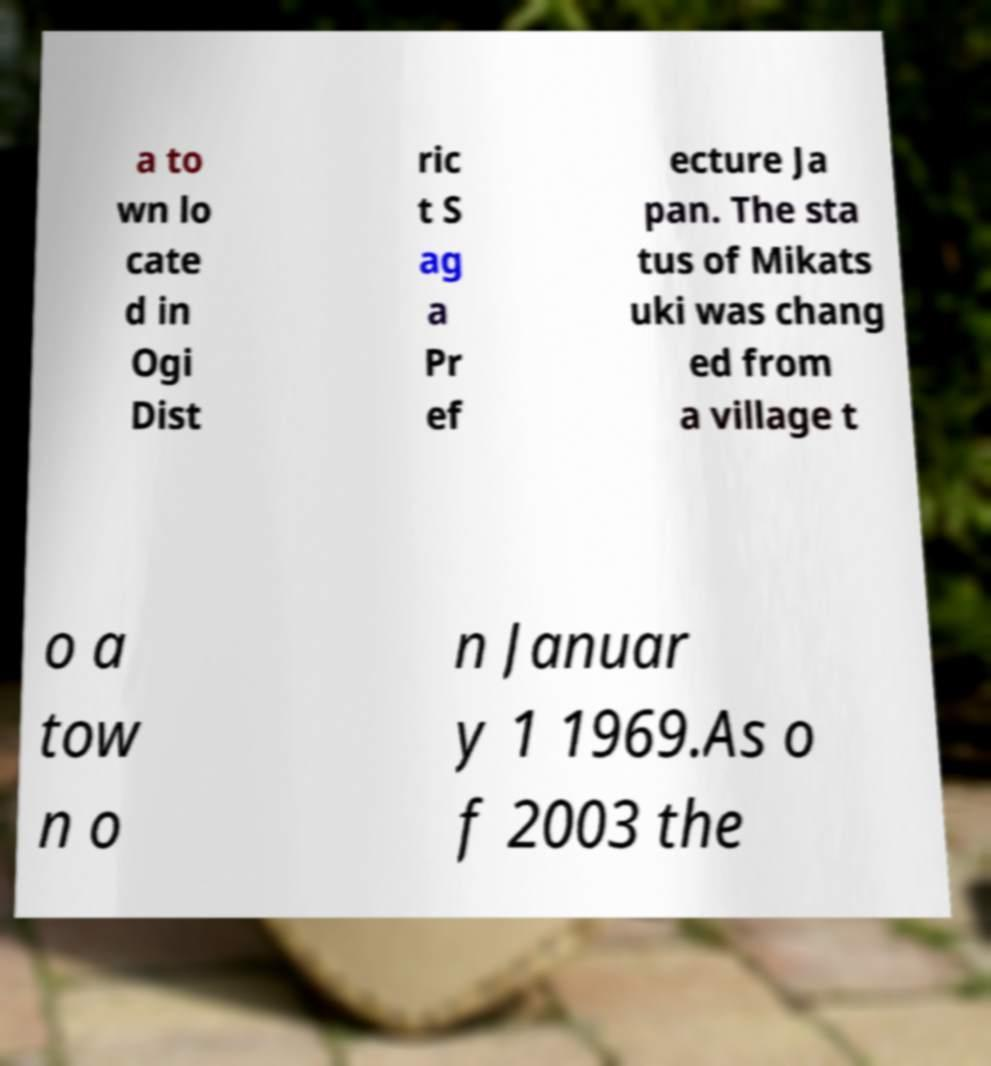Please identify and transcribe the text found in this image. a to wn lo cate d in Ogi Dist ric t S ag a Pr ef ecture Ja pan. The sta tus of Mikats uki was chang ed from a village t o a tow n o n Januar y 1 1969.As o f 2003 the 